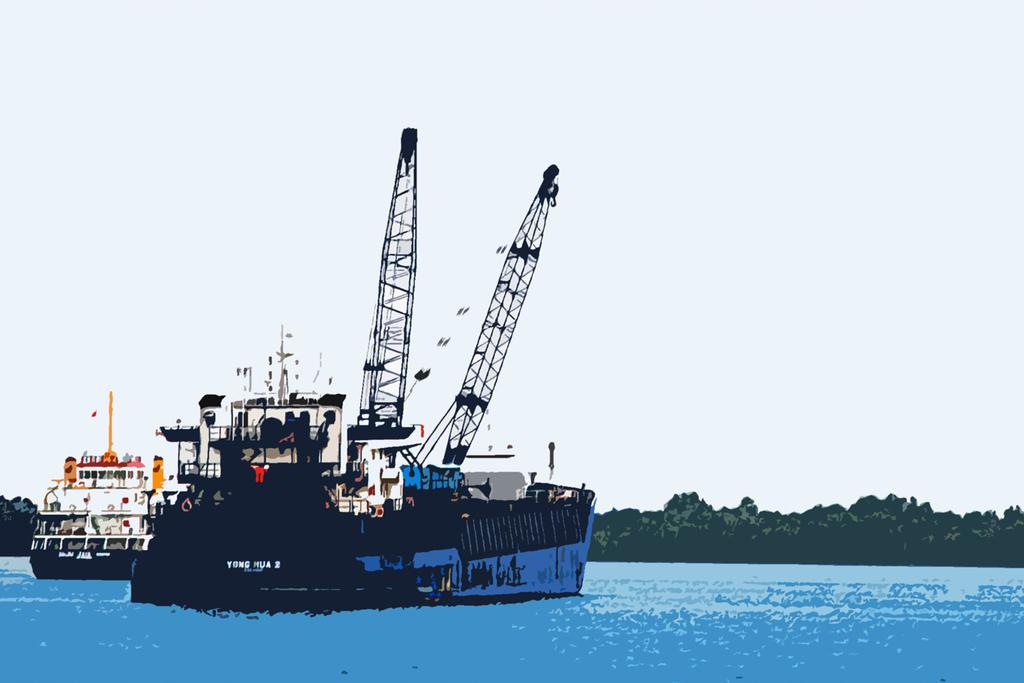What type of artwork is depicted in the image? The image is a painting. What can be seen in the painting? There are ships in the painting, along with water at the bottom, a hill in the background, and the sky visible in the background. What grade of air pollution can be seen in the image? There is no indication of air pollution in the image, as it is a painting depicting ships, water, a hill, and the sky. 